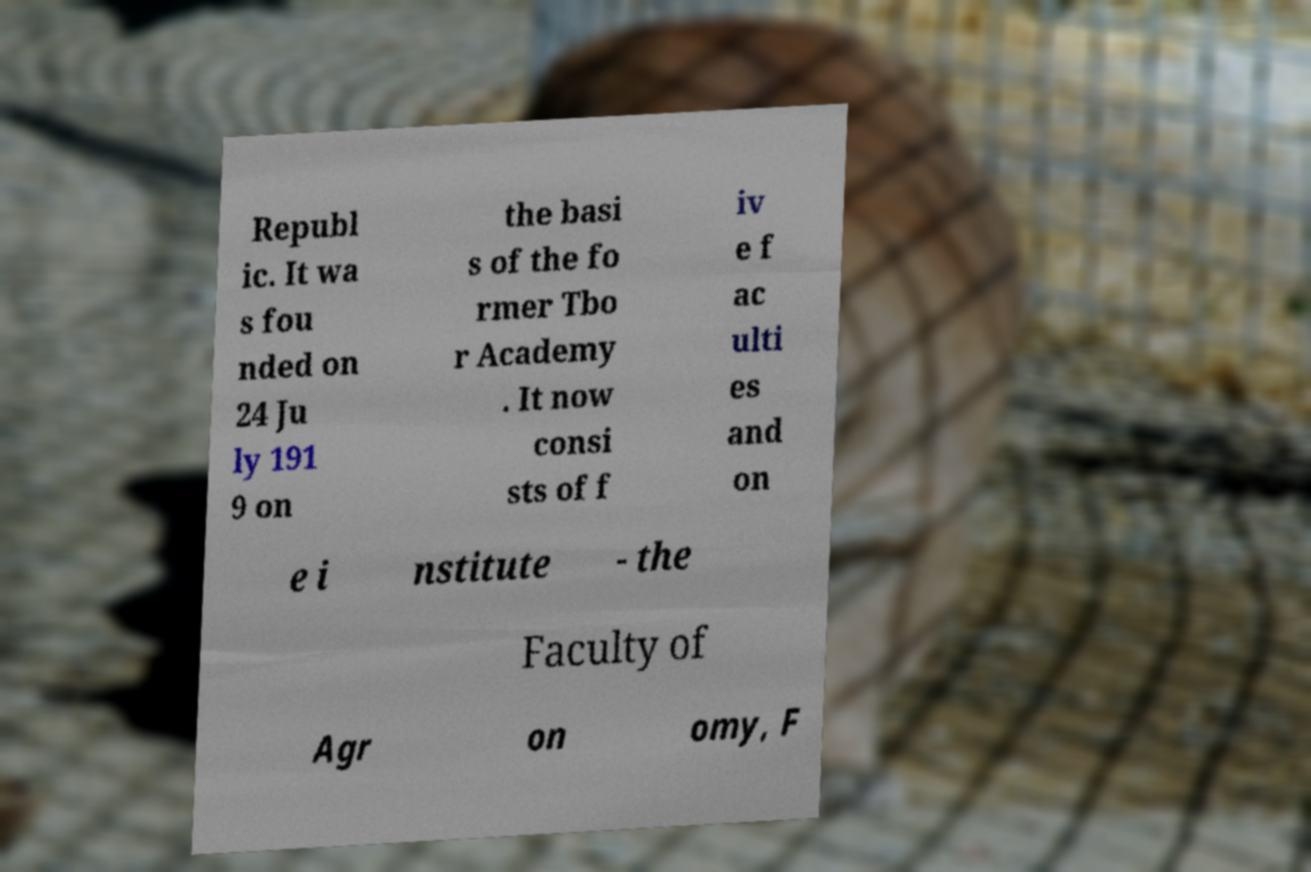What messages or text are displayed in this image? I need them in a readable, typed format. Republ ic. It wa s fou nded on 24 Ju ly 191 9 on the basi s of the fo rmer Tbo r Academy . It now consi sts of f iv e f ac ulti es and on e i nstitute - the Faculty of Agr on omy, F 